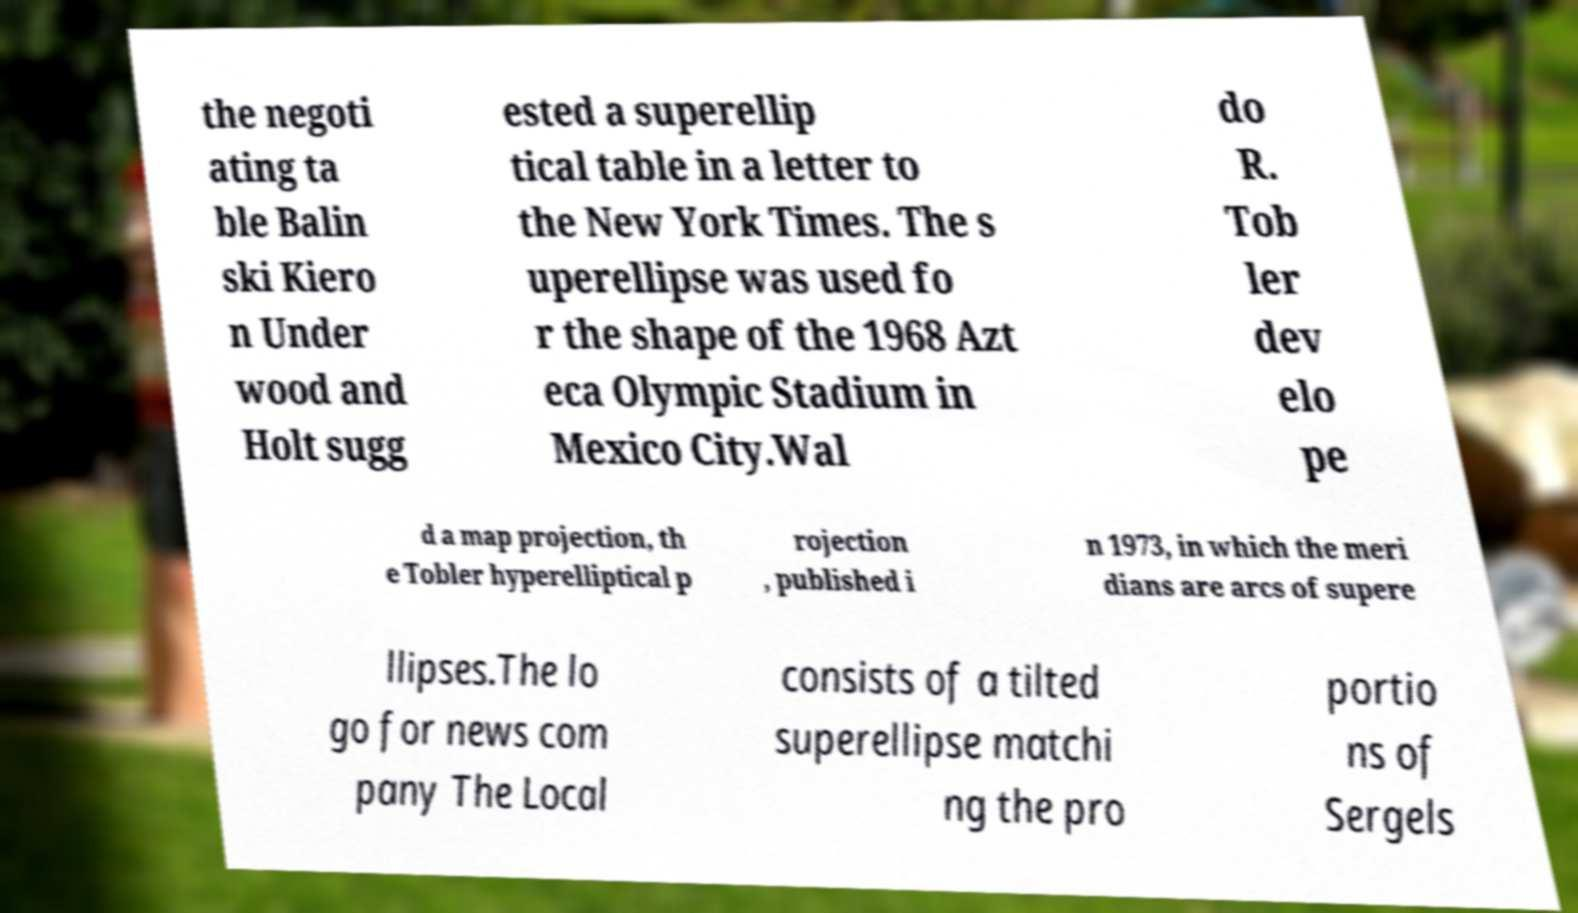Please read and relay the text visible in this image. What does it say? the negoti ating ta ble Balin ski Kiero n Under wood and Holt sugg ested a superellip tical table in a letter to the New York Times. The s uperellipse was used fo r the shape of the 1968 Azt eca Olympic Stadium in Mexico City.Wal do R. Tob ler dev elo pe d a map projection, th e Tobler hyperelliptical p rojection , published i n 1973, in which the meri dians are arcs of supere llipses.The lo go for news com pany The Local consists of a tilted superellipse matchi ng the pro portio ns of Sergels 